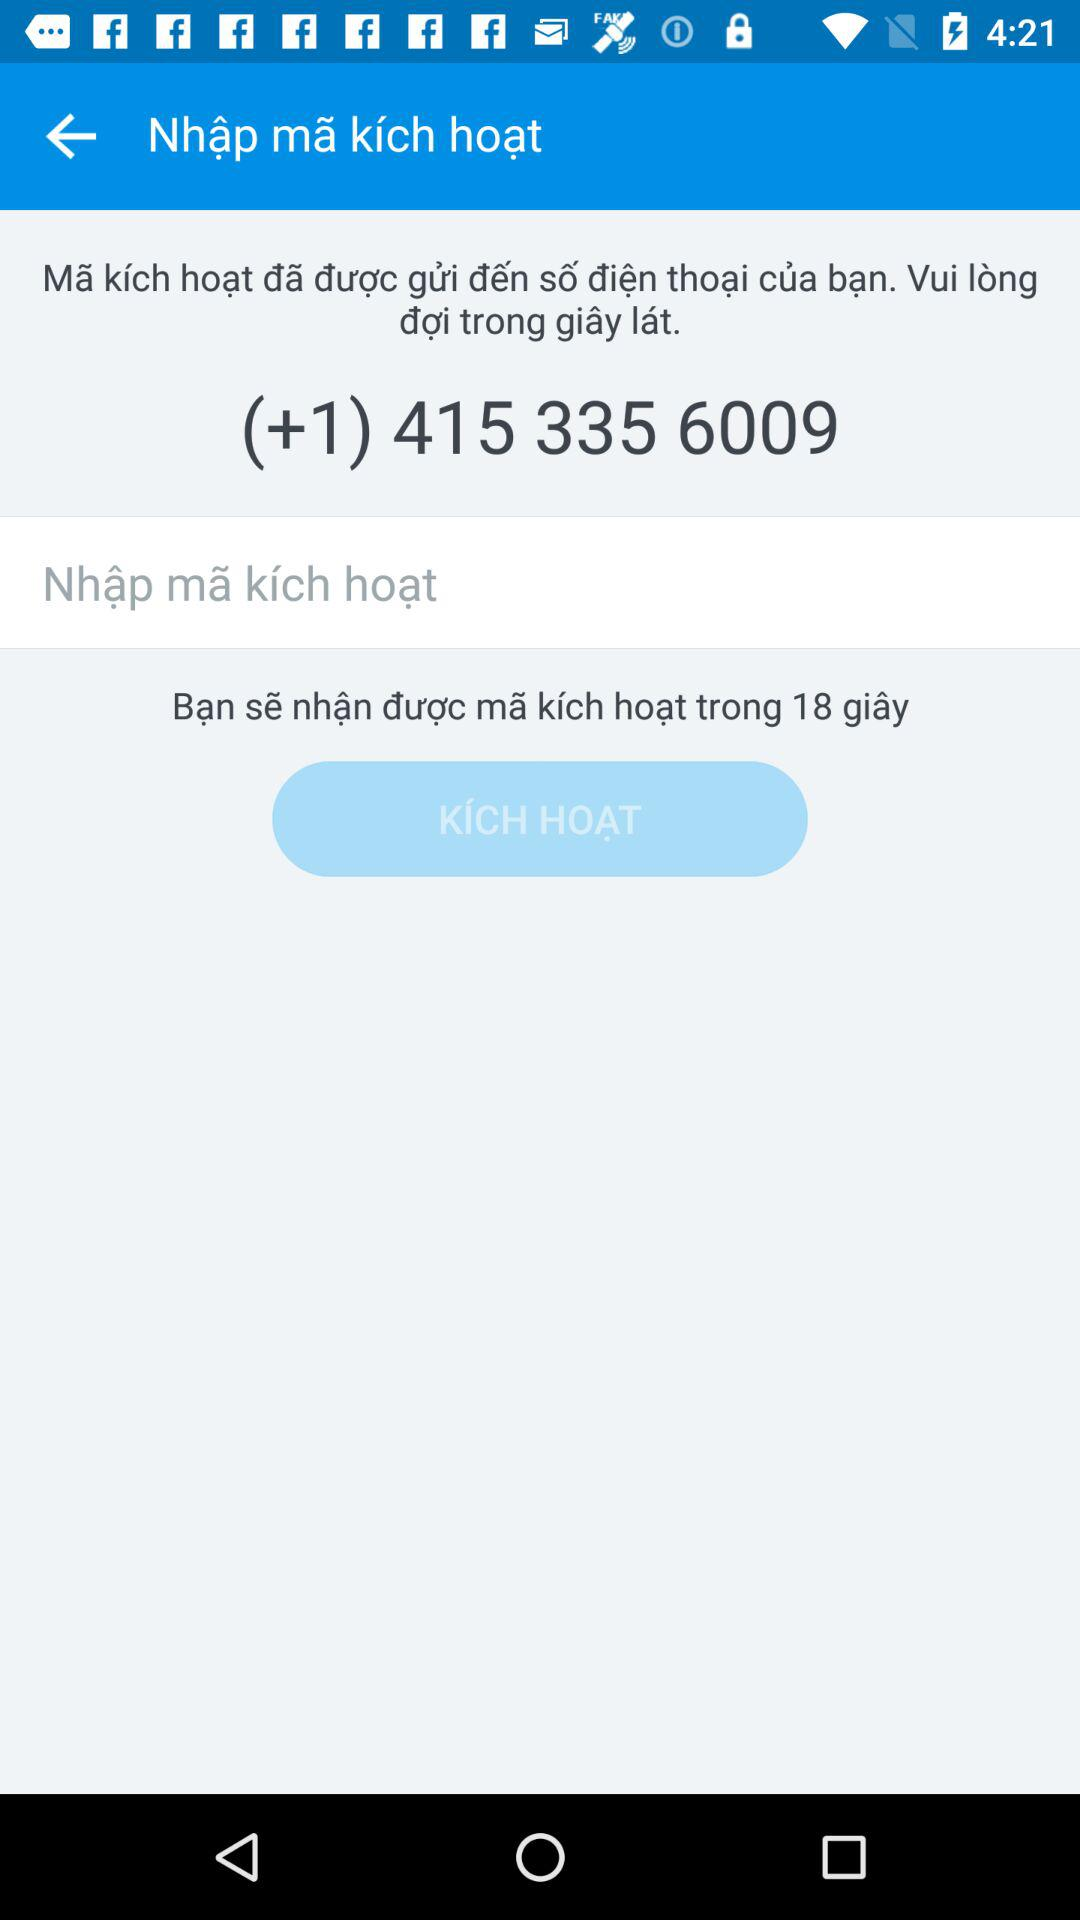How many seconds are left until I receive the activation code?
Answer the question using a single word or phrase. 18 